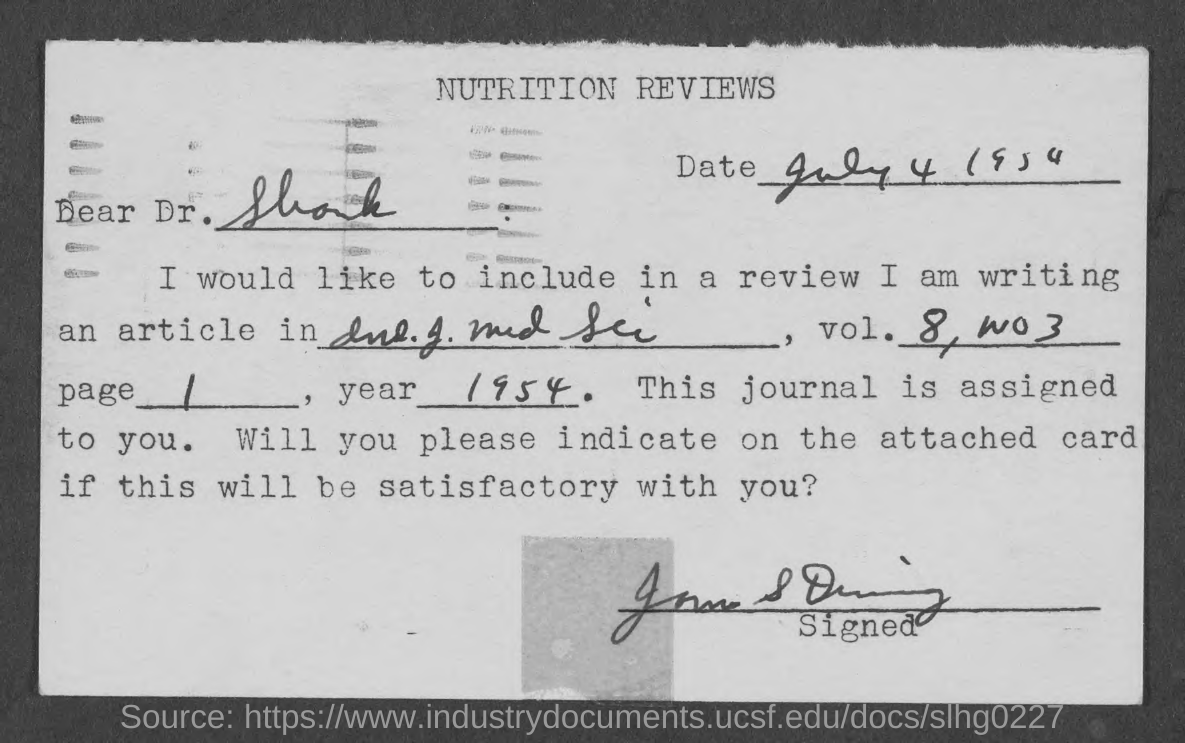What is the Title of the Document ?
Provide a succinct answer. Nutrition reviews. When is the Memorandum dated on  ?
Your answer should be compact. July 4 1954. What is the page number ?
Make the answer very short. 1. Which year written in the year field ?
Your answer should be compact. 1954. 